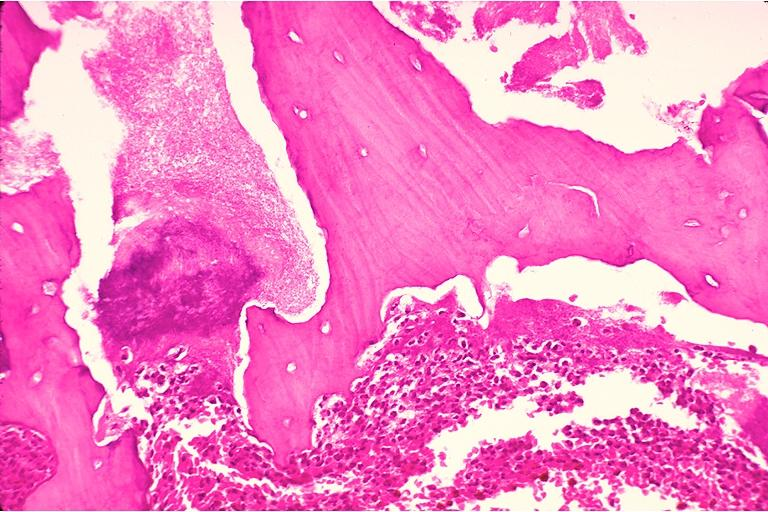where is this?
Answer the question using a single word or phrase. Oral 